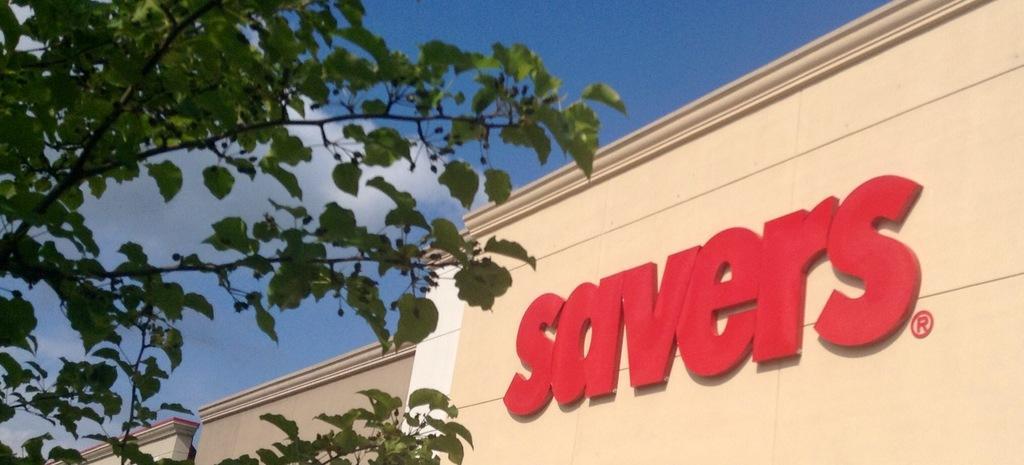Please provide a concise description of this image. On the left side, there is a tree having green color leaves. On the right side, there are red color letters on the wall of a building. In the background, there are buildings and there are clouds in the blue sky. 